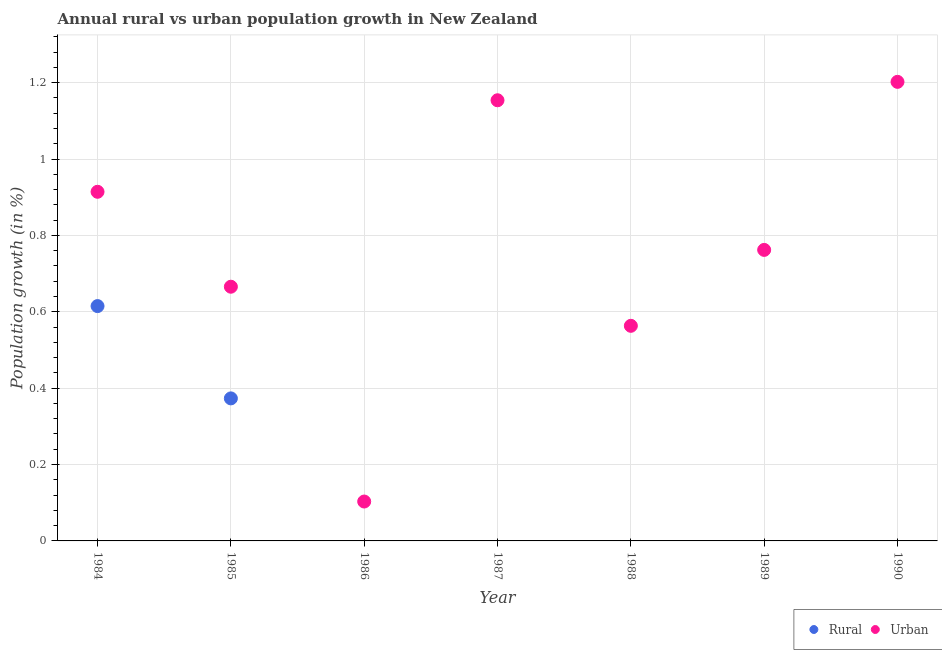How many different coloured dotlines are there?
Keep it short and to the point. 2. What is the rural population growth in 1985?
Make the answer very short. 0.37. Across all years, what is the maximum rural population growth?
Provide a succinct answer. 0.61. What is the total rural population growth in the graph?
Provide a short and direct response. 0.99. What is the difference between the urban population growth in 1985 and that in 1988?
Provide a short and direct response. 0.1. What is the difference between the rural population growth in 1985 and the urban population growth in 1986?
Ensure brevity in your answer.  0.27. What is the average rural population growth per year?
Your answer should be compact. 0.14. In the year 1985, what is the difference between the rural population growth and urban population growth?
Ensure brevity in your answer.  -0.29. What is the ratio of the rural population growth in 1984 to that in 1985?
Make the answer very short. 1.65. Is the urban population growth in 1986 less than that in 1989?
Provide a short and direct response. Yes. What is the difference between the highest and the second highest urban population growth?
Offer a terse response. 0.05. What is the difference between the highest and the lowest rural population growth?
Your answer should be compact. 0.61. Does the urban population growth monotonically increase over the years?
Keep it short and to the point. No. How many dotlines are there?
Make the answer very short. 2. How many years are there in the graph?
Your response must be concise. 7. What is the difference between two consecutive major ticks on the Y-axis?
Give a very brief answer. 0.2. Does the graph contain any zero values?
Your answer should be compact. Yes. Does the graph contain grids?
Offer a terse response. Yes. Where does the legend appear in the graph?
Keep it short and to the point. Bottom right. What is the title of the graph?
Your response must be concise. Annual rural vs urban population growth in New Zealand. Does "Registered firms" appear as one of the legend labels in the graph?
Keep it short and to the point. No. What is the label or title of the Y-axis?
Provide a succinct answer. Population growth (in %). What is the Population growth (in %) in Rural in 1984?
Your response must be concise. 0.61. What is the Population growth (in %) in Urban  in 1984?
Provide a short and direct response. 0.91. What is the Population growth (in %) of Rural in 1985?
Your answer should be compact. 0.37. What is the Population growth (in %) of Urban  in 1985?
Provide a short and direct response. 0.67. What is the Population growth (in %) in Rural in 1986?
Your answer should be very brief. 0. What is the Population growth (in %) in Urban  in 1986?
Provide a succinct answer. 0.1. What is the Population growth (in %) of Urban  in 1987?
Your answer should be compact. 1.15. What is the Population growth (in %) in Rural in 1988?
Ensure brevity in your answer.  0. What is the Population growth (in %) in Urban  in 1988?
Your answer should be compact. 0.56. What is the Population growth (in %) of Urban  in 1989?
Keep it short and to the point. 0.76. What is the Population growth (in %) in Urban  in 1990?
Keep it short and to the point. 1.2. Across all years, what is the maximum Population growth (in %) of Rural?
Give a very brief answer. 0.61. Across all years, what is the maximum Population growth (in %) of Urban ?
Offer a very short reply. 1.2. Across all years, what is the minimum Population growth (in %) of Urban ?
Ensure brevity in your answer.  0.1. What is the total Population growth (in %) of Rural in the graph?
Make the answer very short. 0.99. What is the total Population growth (in %) in Urban  in the graph?
Your answer should be compact. 5.36. What is the difference between the Population growth (in %) of Rural in 1984 and that in 1985?
Offer a very short reply. 0.24. What is the difference between the Population growth (in %) of Urban  in 1984 and that in 1985?
Offer a very short reply. 0.25. What is the difference between the Population growth (in %) of Urban  in 1984 and that in 1986?
Your answer should be very brief. 0.81. What is the difference between the Population growth (in %) in Urban  in 1984 and that in 1987?
Keep it short and to the point. -0.24. What is the difference between the Population growth (in %) in Urban  in 1984 and that in 1988?
Offer a terse response. 0.35. What is the difference between the Population growth (in %) of Urban  in 1984 and that in 1989?
Offer a terse response. 0.15. What is the difference between the Population growth (in %) in Urban  in 1984 and that in 1990?
Your response must be concise. -0.29. What is the difference between the Population growth (in %) of Urban  in 1985 and that in 1986?
Ensure brevity in your answer.  0.56. What is the difference between the Population growth (in %) in Urban  in 1985 and that in 1987?
Offer a terse response. -0.49. What is the difference between the Population growth (in %) in Urban  in 1985 and that in 1988?
Ensure brevity in your answer.  0.1. What is the difference between the Population growth (in %) of Urban  in 1985 and that in 1989?
Keep it short and to the point. -0.1. What is the difference between the Population growth (in %) of Urban  in 1985 and that in 1990?
Your answer should be very brief. -0.54. What is the difference between the Population growth (in %) of Urban  in 1986 and that in 1987?
Your response must be concise. -1.05. What is the difference between the Population growth (in %) of Urban  in 1986 and that in 1988?
Give a very brief answer. -0.46. What is the difference between the Population growth (in %) of Urban  in 1986 and that in 1989?
Provide a short and direct response. -0.66. What is the difference between the Population growth (in %) of Urban  in 1986 and that in 1990?
Keep it short and to the point. -1.1. What is the difference between the Population growth (in %) in Urban  in 1987 and that in 1988?
Make the answer very short. 0.59. What is the difference between the Population growth (in %) in Urban  in 1987 and that in 1989?
Ensure brevity in your answer.  0.39. What is the difference between the Population growth (in %) in Urban  in 1987 and that in 1990?
Give a very brief answer. -0.05. What is the difference between the Population growth (in %) in Urban  in 1988 and that in 1989?
Your response must be concise. -0.2. What is the difference between the Population growth (in %) in Urban  in 1988 and that in 1990?
Ensure brevity in your answer.  -0.64. What is the difference between the Population growth (in %) of Urban  in 1989 and that in 1990?
Your answer should be very brief. -0.44. What is the difference between the Population growth (in %) of Rural in 1984 and the Population growth (in %) of Urban  in 1985?
Give a very brief answer. -0.05. What is the difference between the Population growth (in %) of Rural in 1984 and the Population growth (in %) of Urban  in 1986?
Provide a short and direct response. 0.51. What is the difference between the Population growth (in %) of Rural in 1984 and the Population growth (in %) of Urban  in 1987?
Ensure brevity in your answer.  -0.54. What is the difference between the Population growth (in %) in Rural in 1984 and the Population growth (in %) in Urban  in 1988?
Give a very brief answer. 0.05. What is the difference between the Population growth (in %) in Rural in 1984 and the Population growth (in %) in Urban  in 1989?
Your answer should be compact. -0.15. What is the difference between the Population growth (in %) of Rural in 1984 and the Population growth (in %) of Urban  in 1990?
Offer a terse response. -0.59. What is the difference between the Population growth (in %) in Rural in 1985 and the Population growth (in %) in Urban  in 1986?
Give a very brief answer. 0.27. What is the difference between the Population growth (in %) of Rural in 1985 and the Population growth (in %) of Urban  in 1987?
Provide a short and direct response. -0.78. What is the difference between the Population growth (in %) of Rural in 1985 and the Population growth (in %) of Urban  in 1988?
Offer a terse response. -0.19. What is the difference between the Population growth (in %) of Rural in 1985 and the Population growth (in %) of Urban  in 1989?
Provide a short and direct response. -0.39. What is the difference between the Population growth (in %) in Rural in 1985 and the Population growth (in %) in Urban  in 1990?
Your response must be concise. -0.83. What is the average Population growth (in %) in Rural per year?
Ensure brevity in your answer.  0.14. What is the average Population growth (in %) in Urban  per year?
Provide a short and direct response. 0.77. In the year 1984, what is the difference between the Population growth (in %) of Rural and Population growth (in %) of Urban ?
Keep it short and to the point. -0.3. In the year 1985, what is the difference between the Population growth (in %) in Rural and Population growth (in %) in Urban ?
Keep it short and to the point. -0.29. What is the ratio of the Population growth (in %) in Rural in 1984 to that in 1985?
Your answer should be compact. 1.65. What is the ratio of the Population growth (in %) of Urban  in 1984 to that in 1985?
Ensure brevity in your answer.  1.37. What is the ratio of the Population growth (in %) of Urban  in 1984 to that in 1986?
Provide a succinct answer. 8.86. What is the ratio of the Population growth (in %) in Urban  in 1984 to that in 1987?
Offer a terse response. 0.79. What is the ratio of the Population growth (in %) in Urban  in 1984 to that in 1988?
Your answer should be very brief. 1.62. What is the ratio of the Population growth (in %) of Urban  in 1984 to that in 1989?
Keep it short and to the point. 1.2. What is the ratio of the Population growth (in %) in Urban  in 1984 to that in 1990?
Offer a very short reply. 0.76. What is the ratio of the Population growth (in %) of Urban  in 1985 to that in 1986?
Make the answer very short. 6.45. What is the ratio of the Population growth (in %) in Urban  in 1985 to that in 1987?
Provide a succinct answer. 0.58. What is the ratio of the Population growth (in %) of Urban  in 1985 to that in 1988?
Provide a short and direct response. 1.18. What is the ratio of the Population growth (in %) of Urban  in 1985 to that in 1989?
Provide a succinct answer. 0.87. What is the ratio of the Population growth (in %) in Urban  in 1985 to that in 1990?
Offer a very short reply. 0.55. What is the ratio of the Population growth (in %) of Urban  in 1986 to that in 1987?
Provide a succinct answer. 0.09. What is the ratio of the Population growth (in %) in Urban  in 1986 to that in 1988?
Make the answer very short. 0.18. What is the ratio of the Population growth (in %) of Urban  in 1986 to that in 1989?
Provide a succinct answer. 0.14. What is the ratio of the Population growth (in %) in Urban  in 1986 to that in 1990?
Provide a short and direct response. 0.09. What is the ratio of the Population growth (in %) in Urban  in 1987 to that in 1988?
Offer a very short reply. 2.05. What is the ratio of the Population growth (in %) of Urban  in 1987 to that in 1989?
Keep it short and to the point. 1.51. What is the ratio of the Population growth (in %) of Urban  in 1987 to that in 1990?
Provide a short and direct response. 0.96. What is the ratio of the Population growth (in %) in Urban  in 1988 to that in 1989?
Offer a terse response. 0.74. What is the ratio of the Population growth (in %) in Urban  in 1988 to that in 1990?
Provide a succinct answer. 0.47. What is the ratio of the Population growth (in %) in Urban  in 1989 to that in 1990?
Provide a succinct answer. 0.63. What is the difference between the highest and the second highest Population growth (in %) in Urban ?
Keep it short and to the point. 0.05. What is the difference between the highest and the lowest Population growth (in %) of Rural?
Give a very brief answer. 0.61. What is the difference between the highest and the lowest Population growth (in %) of Urban ?
Offer a terse response. 1.1. 